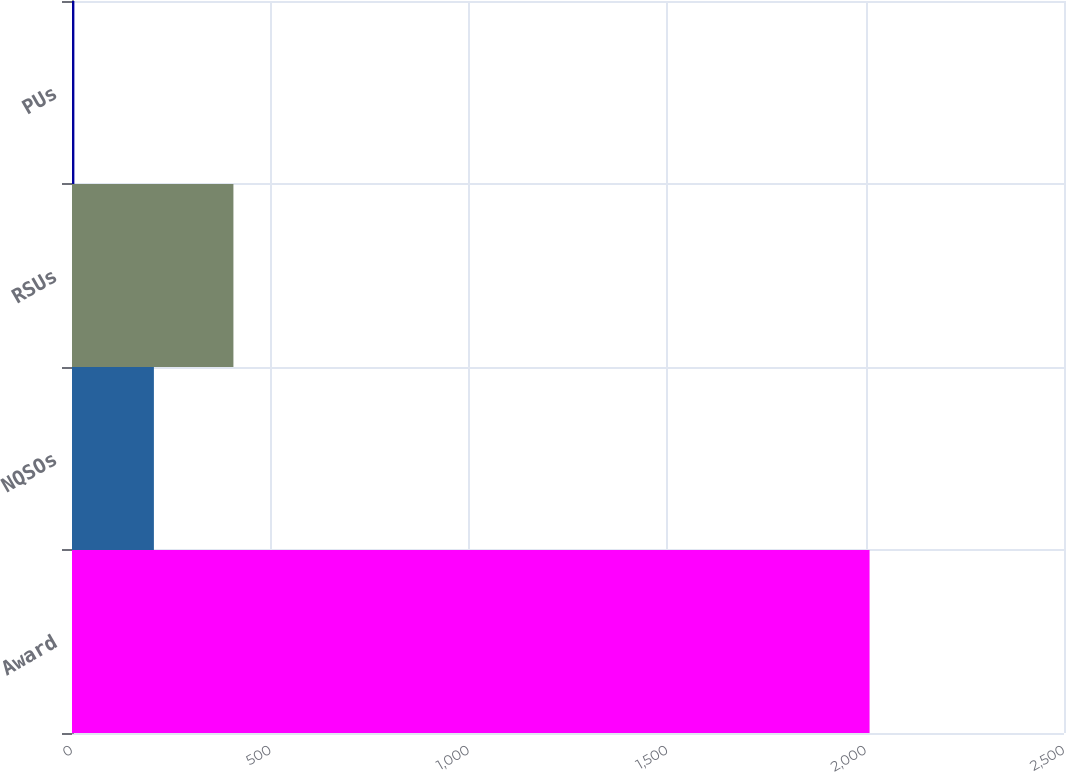Convert chart. <chart><loc_0><loc_0><loc_500><loc_500><bar_chart><fcel>Award<fcel>NQSOs<fcel>RSUs<fcel>PUs<nl><fcel>2010<fcel>206.4<fcel>406.8<fcel>6<nl></chart> 